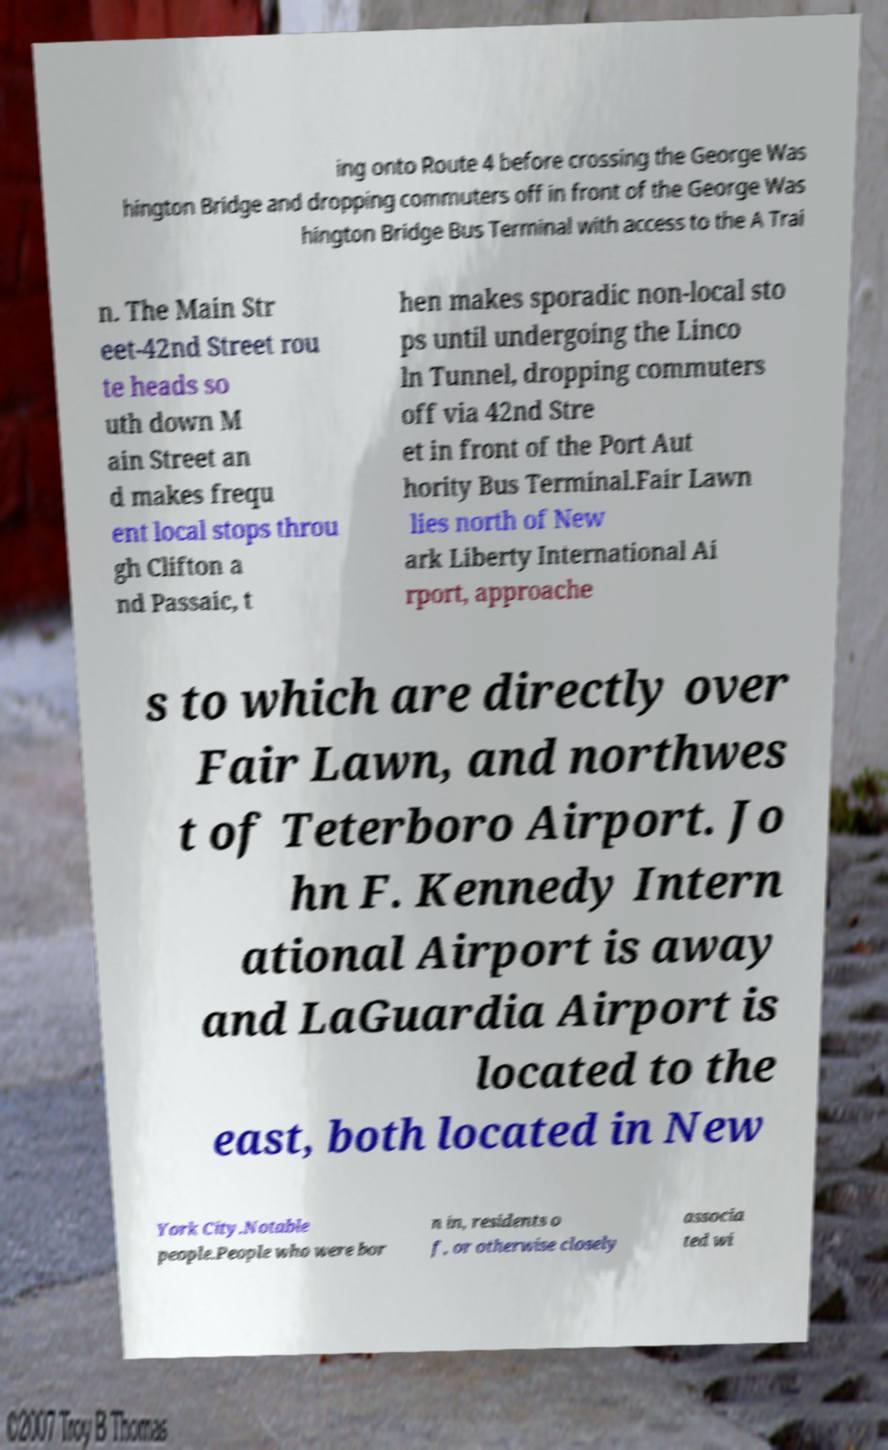For documentation purposes, I need the text within this image transcribed. Could you provide that? ing onto Route 4 before crossing the George Was hington Bridge and dropping commuters off in front of the George Was hington Bridge Bus Terminal with access to the A Trai n. The Main Str eet-42nd Street rou te heads so uth down M ain Street an d makes frequ ent local stops throu gh Clifton a nd Passaic, t hen makes sporadic non-local sto ps until undergoing the Linco ln Tunnel, dropping commuters off via 42nd Stre et in front of the Port Aut hority Bus Terminal.Fair Lawn lies north of New ark Liberty International Ai rport, approache s to which are directly over Fair Lawn, and northwes t of Teterboro Airport. Jo hn F. Kennedy Intern ational Airport is away and LaGuardia Airport is located to the east, both located in New York City.Notable people.People who were bor n in, residents o f, or otherwise closely associa ted wi 